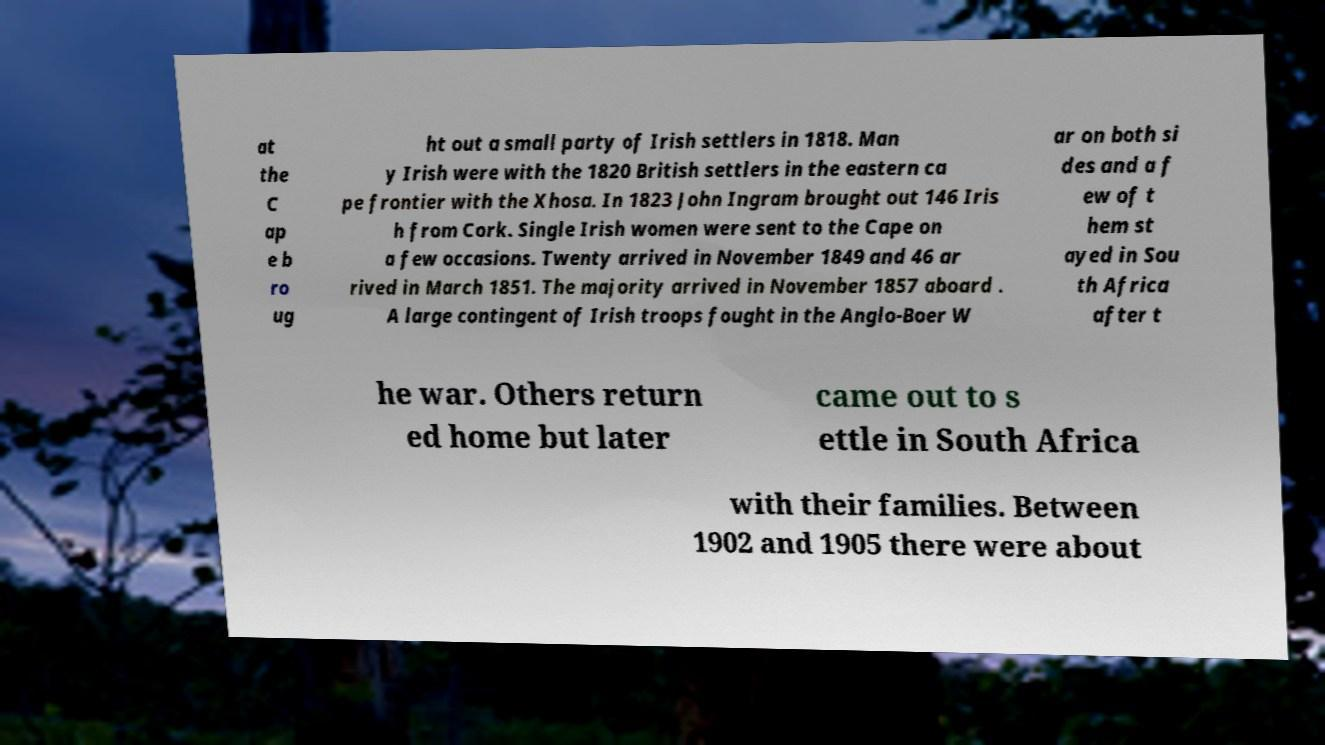What messages or text are displayed in this image? I need them in a readable, typed format. at the C ap e b ro ug ht out a small party of Irish settlers in 1818. Man y Irish were with the 1820 British settlers in the eastern ca pe frontier with the Xhosa. In 1823 John Ingram brought out 146 Iris h from Cork. Single Irish women were sent to the Cape on a few occasions. Twenty arrived in November 1849 and 46 ar rived in March 1851. The majority arrived in November 1857 aboard . A large contingent of Irish troops fought in the Anglo-Boer W ar on both si des and a f ew of t hem st ayed in Sou th Africa after t he war. Others return ed home but later came out to s ettle in South Africa with their families. Between 1902 and 1905 there were about 